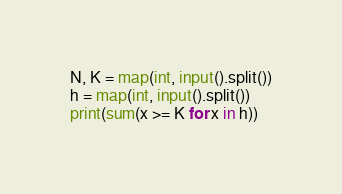<code> <loc_0><loc_0><loc_500><loc_500><_Python_>N, K = map(int, input().split())
h = map(int, input().split())
print(sum(x >= K for x in h))</code> 